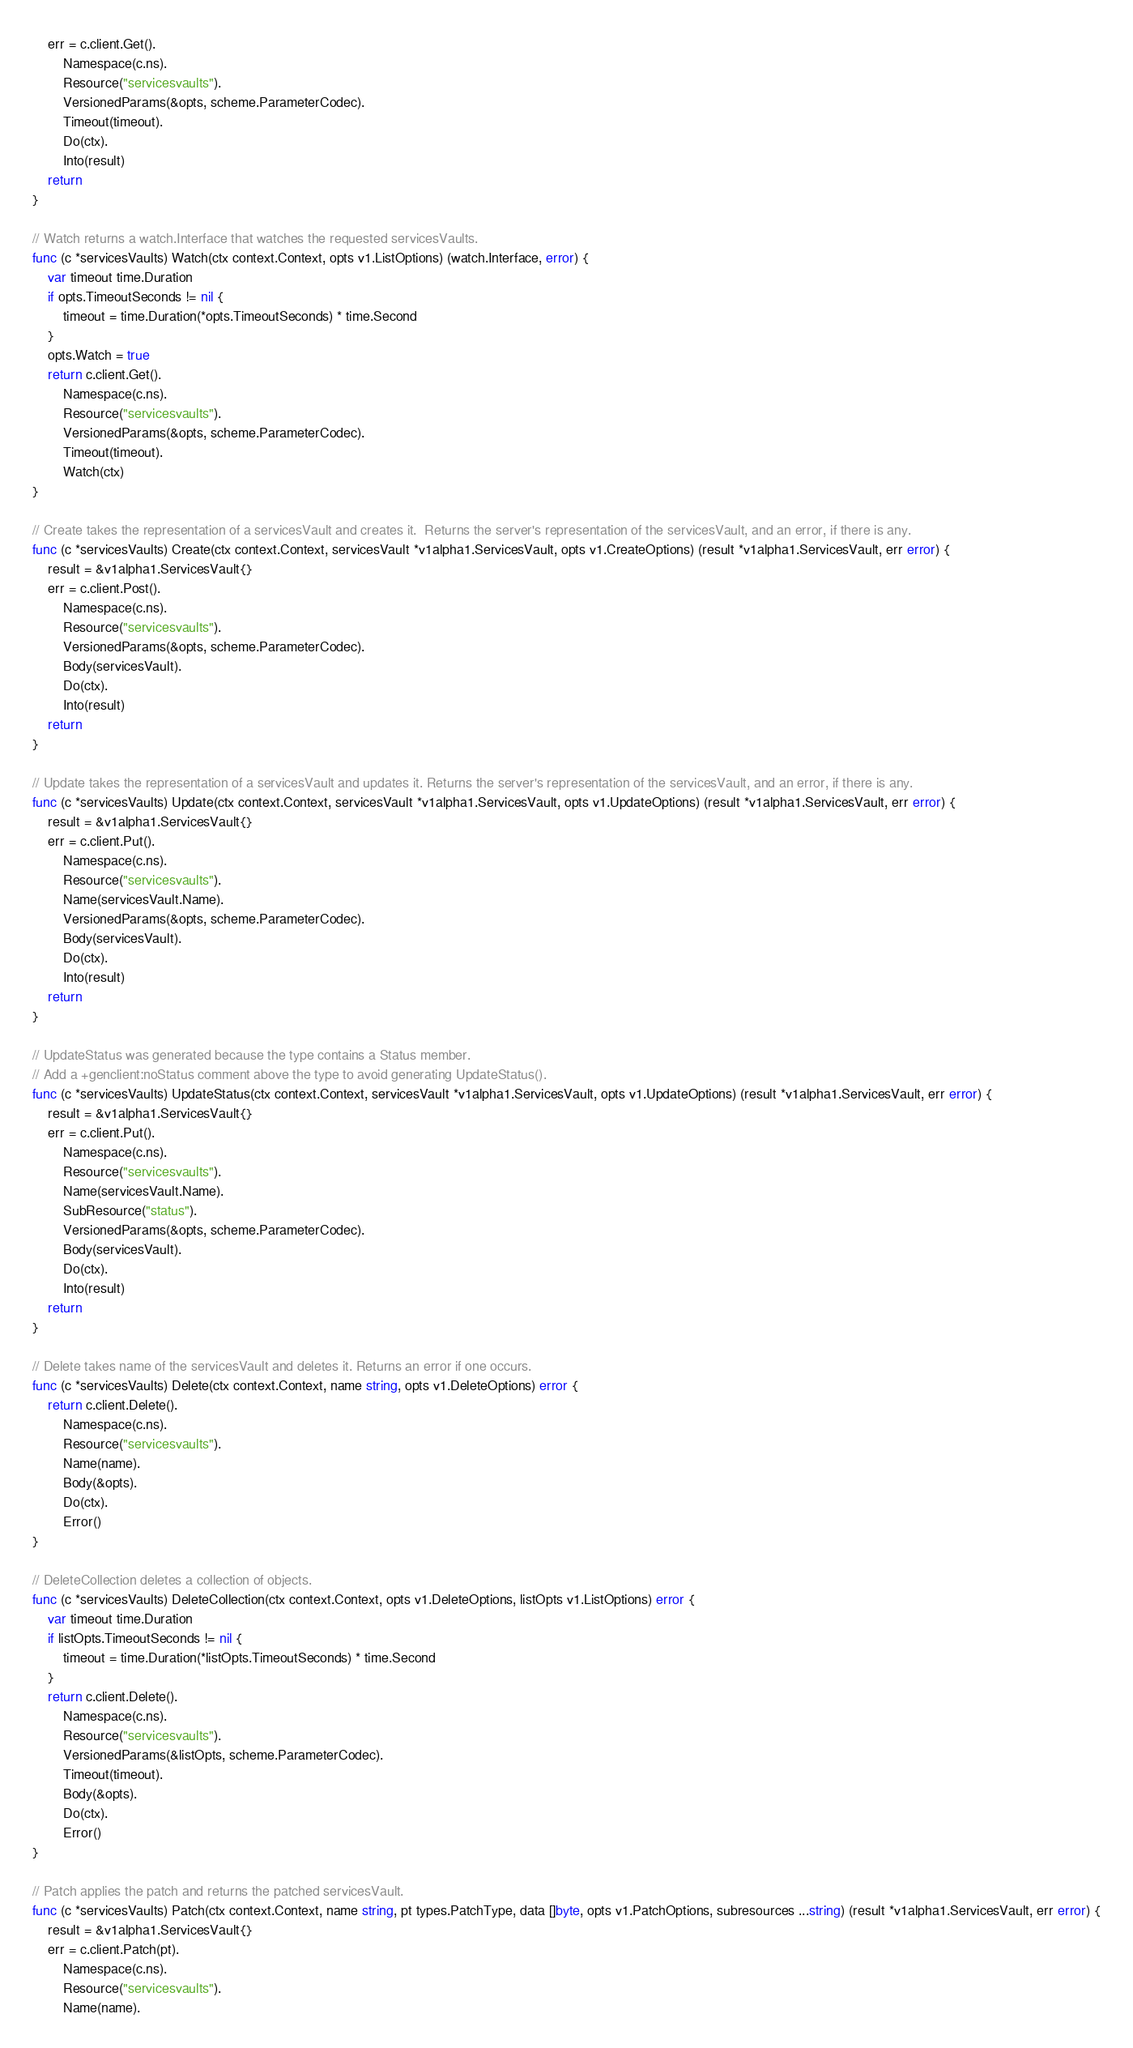Convert code to text. <code><loc_0><loc_0><loc_500><loc_500><_Go_>	err = c.client.Get().
		Namespace(c.ns).
		Resource("servicesvaults").
		VersionedParams(&opts, scheme.ParameterCodec).
		Timeout(timeout).
		Do(ctx).
		Into(result)
	return
}

// Watch returns a watch.Interface that watches the requested servicesVaults.
func (c *servicesVaults) Watch(ctx context.Context, opts v1.ListOptions) (watch.Interface, error) {
	var timeout time.Duration
	if opts.TimeoutSeconds != nil {
		timeout = time.Duration(*opts.TimeoutSeconds) * time.Second
	}
	opts.Watch = true
	return c.client.Get().
		Namespace(c.ns).
		Resource("servicesvaults").
		VersionedParams(&opts, scheme.ParameterCodec).
		Timeout(timeout).
		Watch(ctx)
}

// Create takes the representation of a servicesVault and creates it.  Returns the server's representation of the servicesVault, and an error, if there is any.
func (c *servicesVaults) Create(ctx context.Context, servicesVault *v1alpha1.ServicesVault, opts v1.CreateOptions) (result *v1alpha1.ServicesVault, err error) {
	result = &v1alpha1.ServicesVault{}
	err = c.client.Post().
		Namespace(c.ns).
		Resource("servicesvaults").
		VersionedParams(&opts, scheme.ParameterCodec).
		Body(servicesVault).
		Do(ctx).
		Into(result)
	return
}

// Update takes the representation of a servicesVault and updates it. Returns the server's representation of the servicesVault, and an error, if there is any.
func (c *servicesVaults) Update(ctx context.Context, servicesVault *v1alpha1.ServicesVault, opts v1.UpdateOptions) (result *v1alpha1.ServicesVault, err error) {
	result = &v1alpha1.ServicesVault{}
	err = c.client.Put().
		Namespace(c.ns).
		Resource("servicesvaults").
		Name(servicesVault.Name).
		VersionedParams(&opts, scheme.ParameterCodec).
		Body(servicesVault).
		Do(ctx).
		Into(result)
	return
}

// UpdateStatus was generated because the type contains a Status member.
// Add a +genclient:noStatus comment above the type to avoid generating UpdateStatus().
func (c *servicesVaults) UpdateStatus(ctx context.Context, servicesVault *v1alpha1.ServicesVault, opts v1.UpdateOptions) (result *v1alpha1.ServicesVault, err error) {
	result = &v1alpha1.ServicesVault{}
	err = c.client.Put().
		Namespace(c.ns).
		Resource("servicesvaults").
		Name(servicesVault.Name).
		SubResource("status").
		VersionedParams(&opts, scheme.ParameterCodec).
		Body(servicesVault).
		Do(ctx).
		Into(result)
	return
}

// Delete takes name of the servicesVault and deletes it. Returns an error if one occurs.
func (c *servicesVaults) Delete(ctx context.Context, name string, opts v1.DeleteOptions) error {
	return c.client.Delete().
		Namespace(c.ns).
		Resource("servicesvaults").
		Name(name).
		Body(&opts).
		Do(ctx).
		Error()
}

// DeleteCollection deletes a collection of objects.
func (c *servicesVaults) DeleteCollection(ctx context.Context, opts v1.DeleteOptions, listOpts v1.ListOptions) error {
	var timeout time.Duration
	if listOpts.TimeoutSeconds != nil {
		timeout = time.Duration(*listOpts.TimeoutSeconds) * time.Second
	}
	return c.client.Delete().
		Namespace(c.ns).
		Resource("servicesvaults").
		VersionedParams(&listOpts, scheme.ParameterCodec).
		Timeout(timeout).
		Body(&opts).
		Do(ctx).
		Error()
}

// Patch applies the patch and returns the patched servicesVault.
func (c *servicesVaults) Patch(ctx context.Context, name string, pt types.PatchType, data []byte, opts v1.PatchOptions, subresources ...string) (result *v1alpha1.ServicesVault, err error) {
	result = &v1alpha1.ServicesVault{}
	err = c.client.Patch(pt).
		Namespace(c.ns).
		Resource("servicesvaults").
		Name(name).</code> 